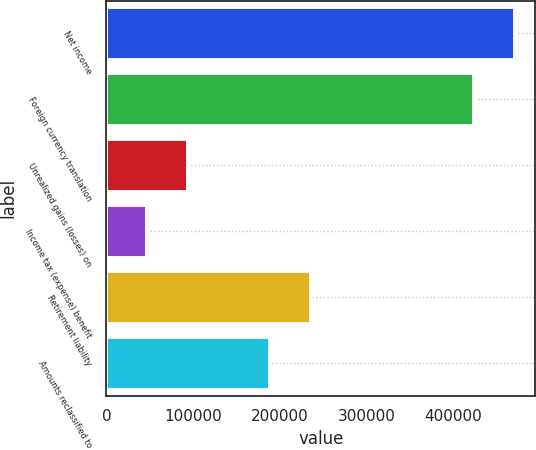<chart> <loc_0><loc_0><loc_500><loc_500><bar_chart><fcel>Net income<fcel>Foreign currency translation<fcel>Unrealized gains (losses) on<fcel>Income tax (expense) benefit<fcel>Retirement liability<fcel>Amounts reclassified to<nl><fcel>471103<fcel>423995<fcel>94242.2<fcel>47134.6<fcel>235565<fcel>188457<nl></chart> 